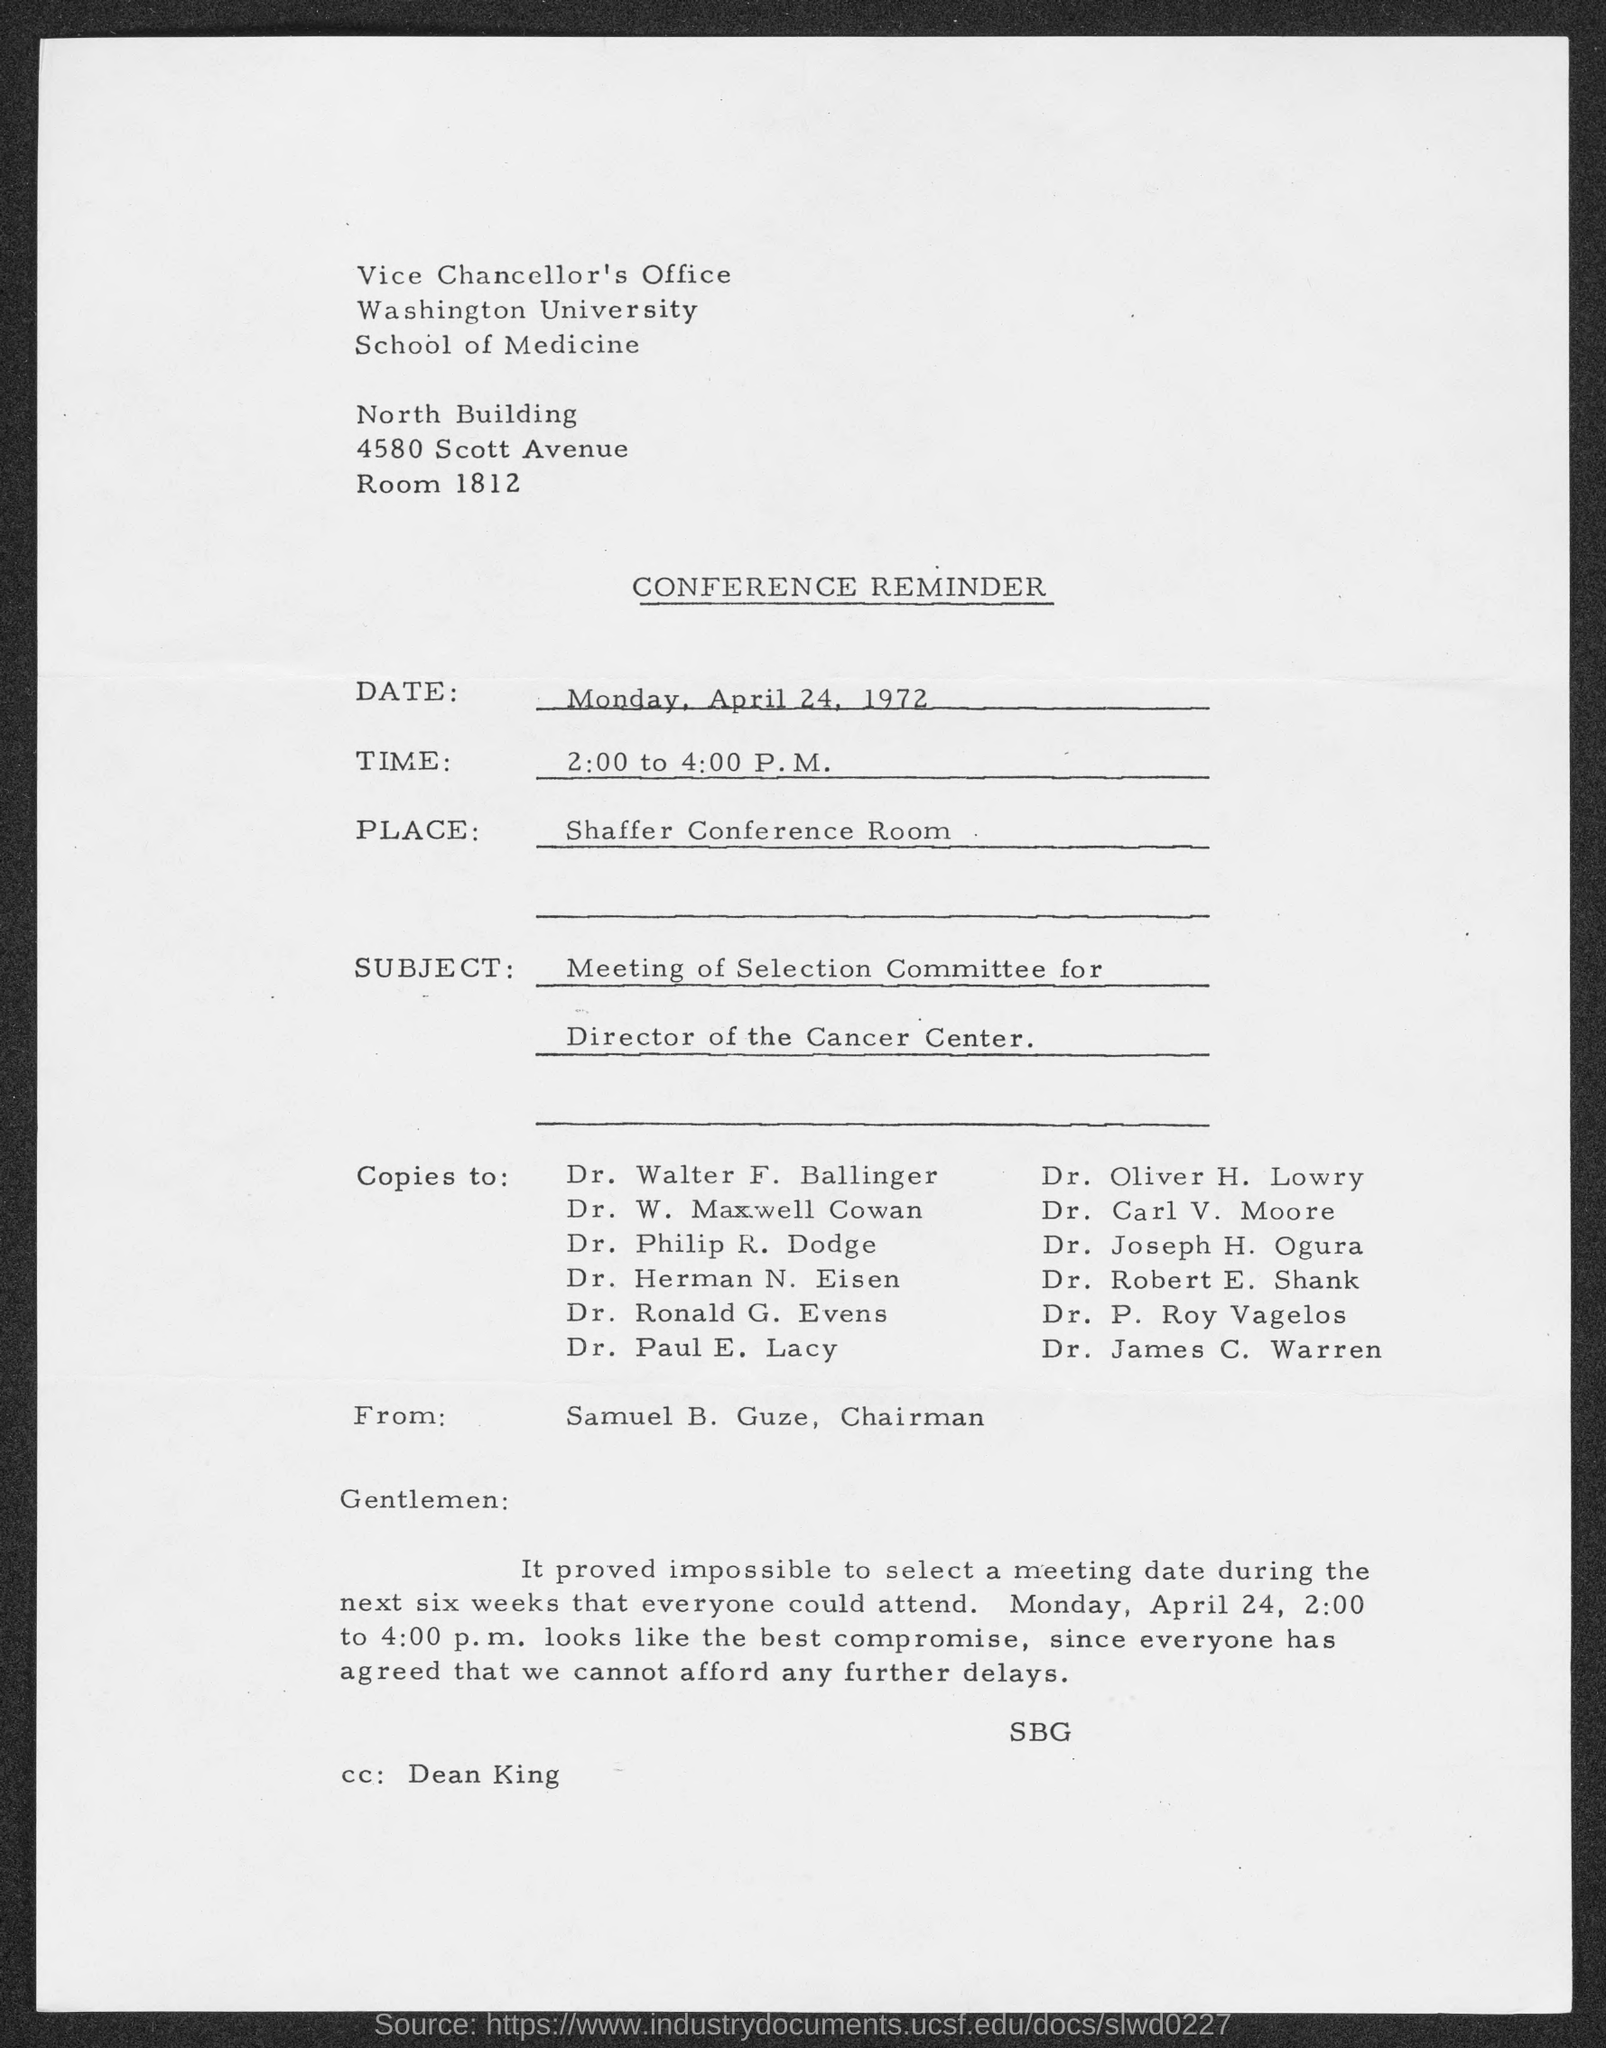Draw attention to some important aspects in this diagram. The conference reminder mentions Dean King in the cc field. The Shaffer Conference Room is the location of the conference as stated in the document. The reminder is from Samuel B. Guze, the Chairman. The given document is a conference reminder. The subject mentioned in the conference reminder is the meeting of the Selection Committee for the Director of the Cancer Center. 